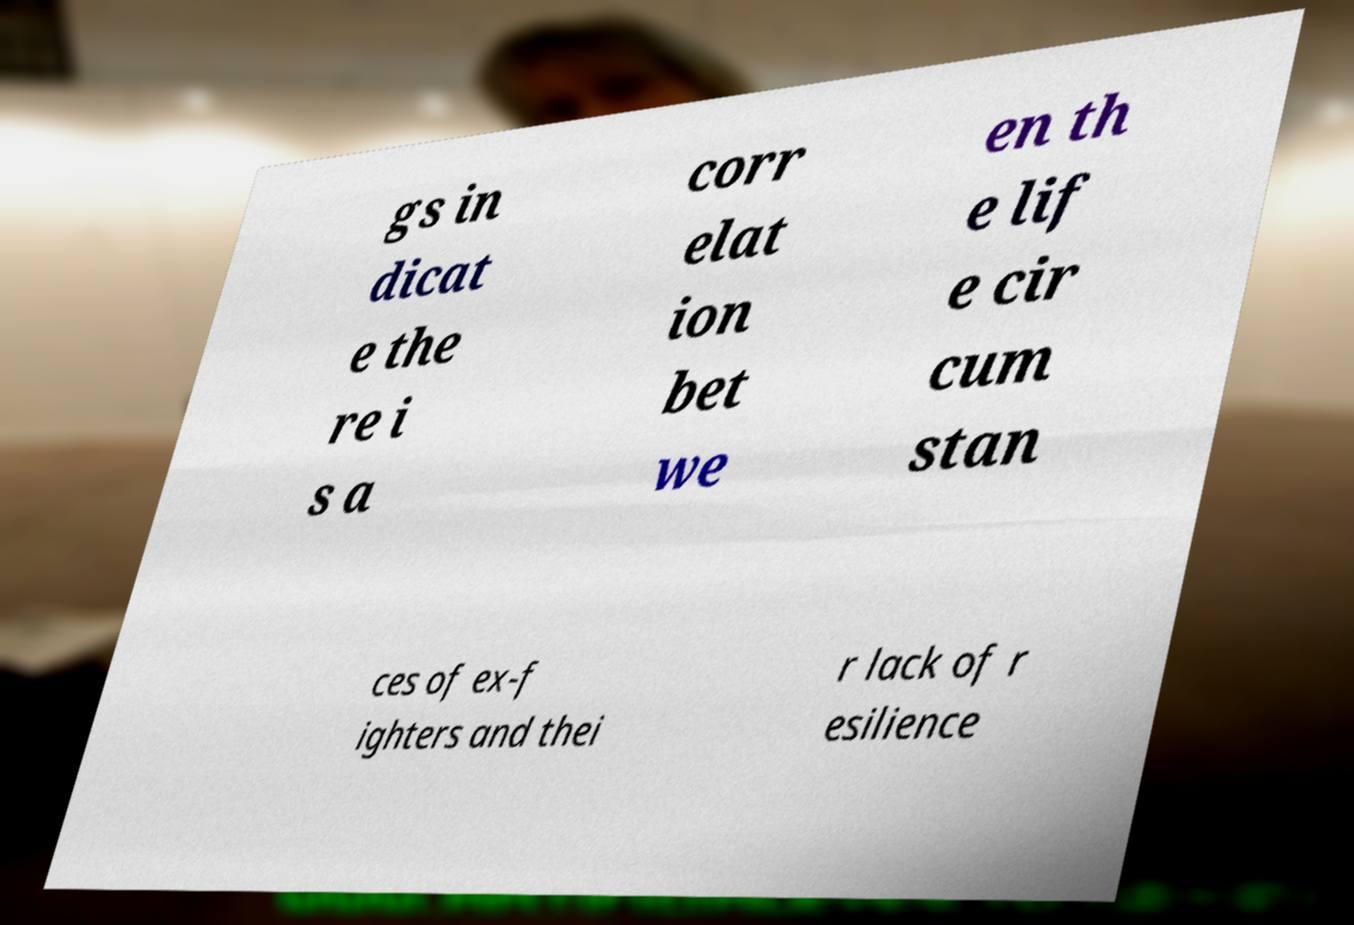I need the written content from this picture converted into text. Can you do that? gs in dicat e the re i s a corr elat ion bet we en th e lif e cir cum stan ces of ex-f ighters and thei r lack of r esilience 